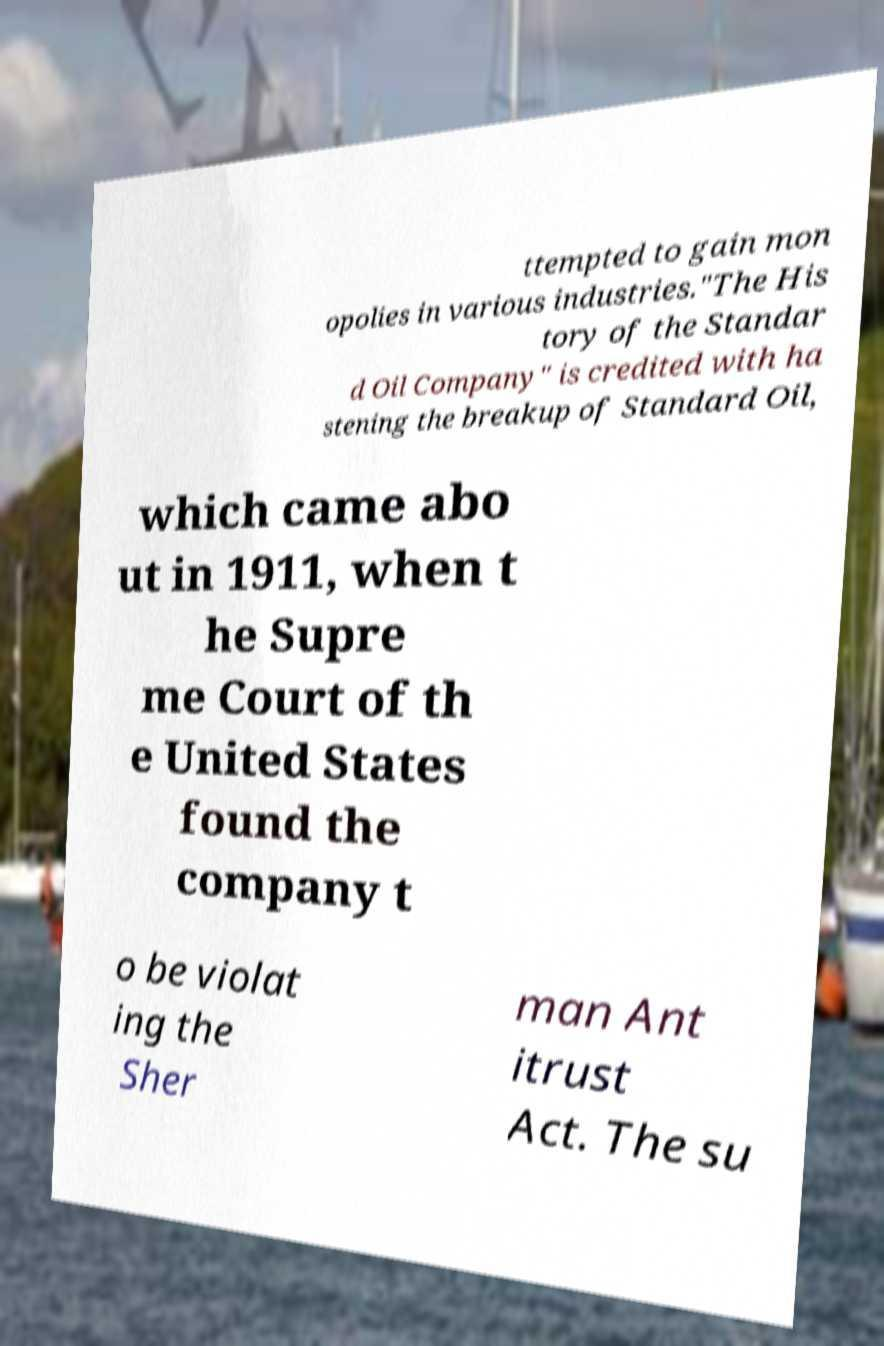Please identify and transcribe the text found in this image. ttempted to gain mon opolies in various industries."The His tory of the Standar d Oil Company" is credited with ha stening the breakup of Standard Oil, which came abo ut in 1911, when t he Supre me Court of th e United States found the company t o be violat ing the Sher man Ant itrust Act. The su 